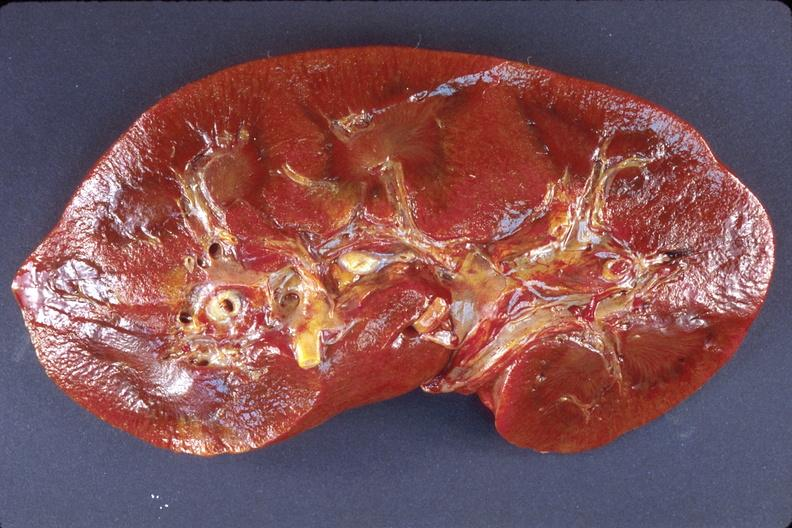does malignant histiocytosis show kidney, amyloidosis?
Answer the question using a single word or phrase. No 